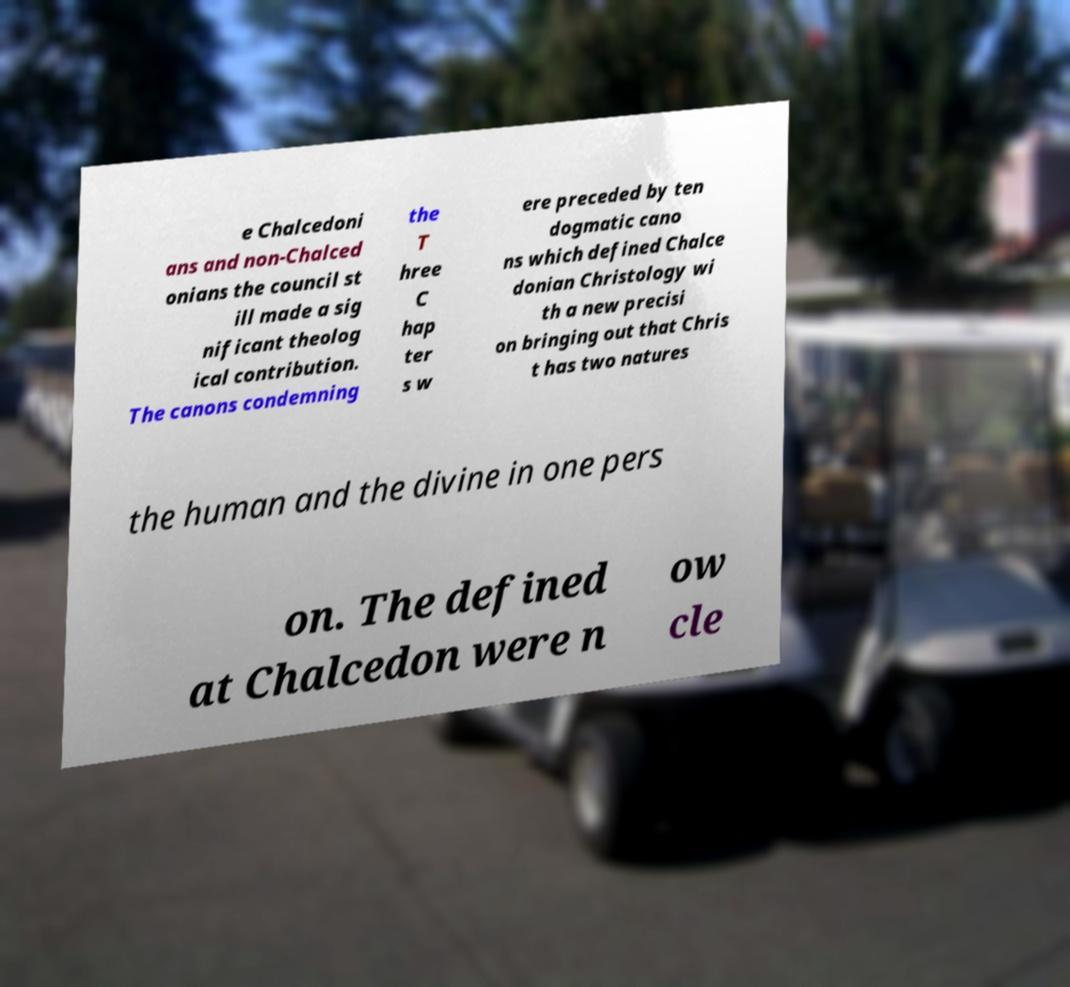Could you assist in decoding the text presented in this image and type it out clearly? e Chalcedoni ans and non-Chalced onians the council st ill made a sig nificant theolog ical contribution. The canons condemning the T hree C hap ter s w ere preceded by ten dogmatic cano ns which defined Chalce donian Christology wi th a new precisi on bringing out that Chris t has two natures the human and the divine in one pers on. The defined at Chalcedon were n ow cle 